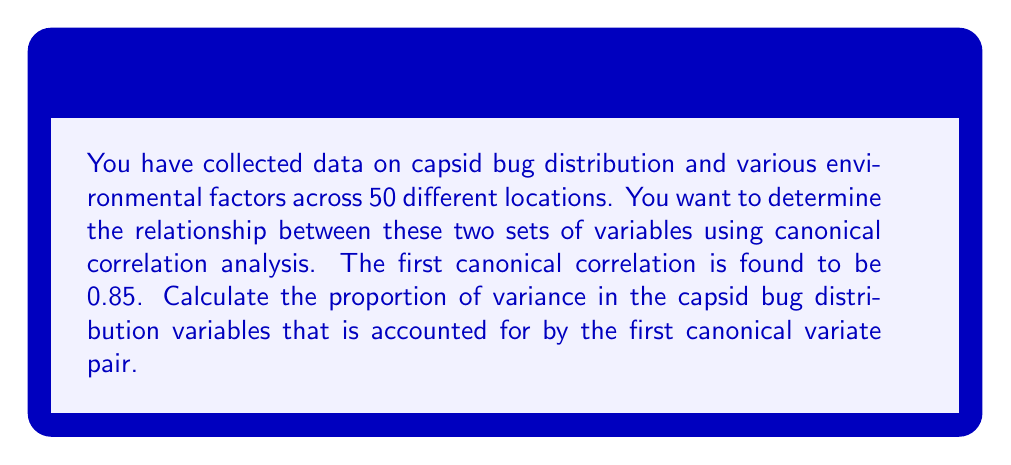What is the answer to this math problem? To solve this problem, we need to understand the concept of canonical correlation analysis and how to interpret its results. Let's break it down step by step:

1) Canonical correlation analysis (CCA) is a method used to identify and measure the associations between two sets of variables. In this case, we have:
   - Set 1: Capsid bug distribution variables
   - Set 2: Environmental factor variables

2) The canonical correlation coefficient represents the strength of the relationship between the canonical variates (linear combinations of the original variables in each set).

3) The first canonical correlation is usually the strongest and most important one. In this case, it's given as 0.85.

4) To find the proportion of variance accounted for by the first canonical variate pair, we need to square the canonical correlation coefficient. This is because the squared canonical correlation represents the shared variance between the two canonical variates.

5) The calculation is as follows:

   $$\text{Proportion of variance} = r_c^2$$

   Where $r_c$ is the canonical correlation coefficient.

6) Plugging in our value:

   $$\text{Proportion of variance} = (0.85)^2 = 0.7225$$

7) To express this as a percentage, we multiply by 100:

   $$0.7225 \times 100 = 72.25\%$$

Therefore, the first canonical variate pair accounts for 72.25% of the variance in the capsid bug distribution variables.
Answer: The proportion of variance in the capsid bug distribution variables accounted for by the first canonical variate pair is 0.7225 or 72.25%. 